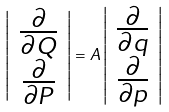Convert formula to latex. <formula><loc_0><loc_0><loc_500><loc_500>\left | \begin{array} { c } \frac { \partial } { \partial Q } \\ \frac { \partial } { \partial P } \end{array} \right | = A \left | \begin{array} { c } \frac { \partial } { \partial q } \\ \frac { \partial } { \partial p } \end{array} \right |</formula> 